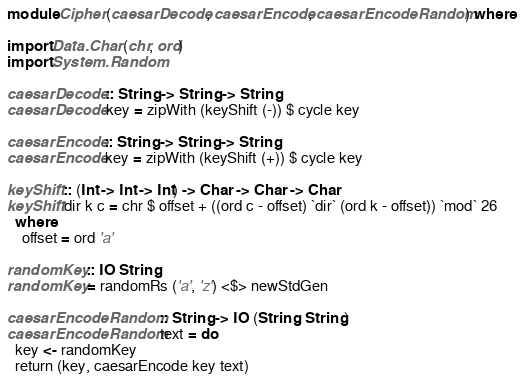Convert code to text. <code><loc_0><loc_0><loc_500><loc_500><_Haskell_>module Cipher (caesarDecode, caesarEncode, caesarEncodeRandom) where

import Data.Char (chr, ord)
import System.Random

caesarDecode :: String -> String -> String
caesarDecode key = zipWith (keyShift (-)) $ cycle key

caesarEncode :: String -> String -> String
caesarEncode key = zipWith (keyShift (+)) $ cycle key

keyShift :: (Int -> Int -> Int) -> Char -> Char -> Char
keyShift dir k c = chr $ offset + ((ord c - offset) `dir` (ord k - offset)) `mod` 26
  where
    offset = ord 'a'

randomKey :: IO String
randomKey = randomRs ('a', 'z') <$> newStdGen

caesarEncodeRandom :: String -> IO (String, String)
caesarEncodeRandom text = do
  key <- randomKey
  return (key, caesarEncode key text)
</code> 